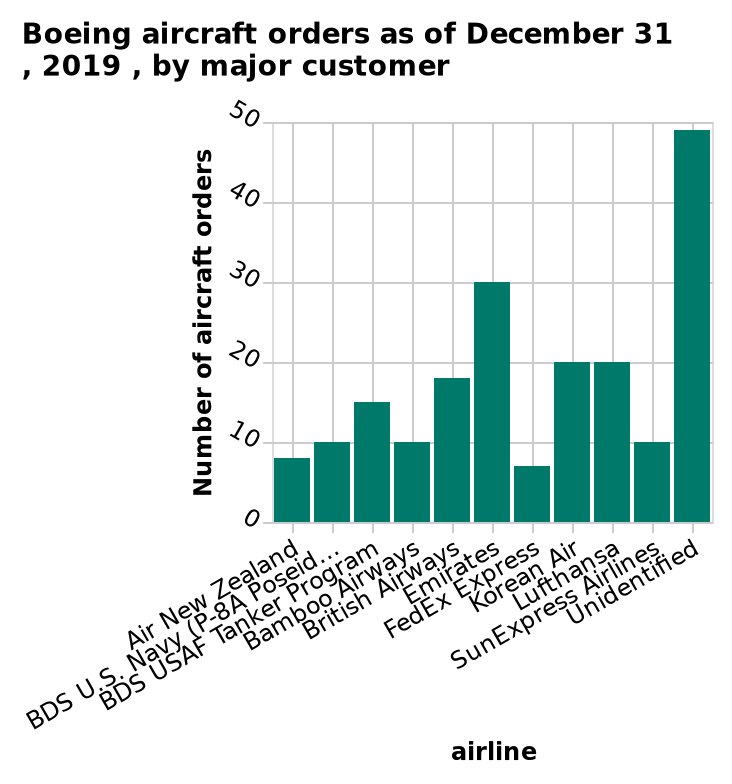<image>
What is the scale of the y-axis?  The scale of the y-axis is linear. What does the x-axis represent in the bar plot? The x-axis represents the major customers in the airline industry, starting from Air New Zealand and ending at Unidentified. 